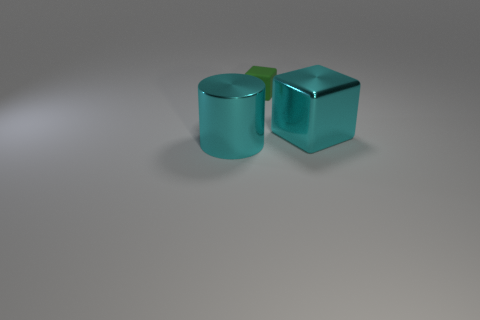How many big cyan things are to the left of the large metallic block and to the right of the small matte cube? There are no big cyan things located to the left of the large metallic block and to the right of the small matte cube. The image shows only two cyan objects, and neither fits the criteria described. 